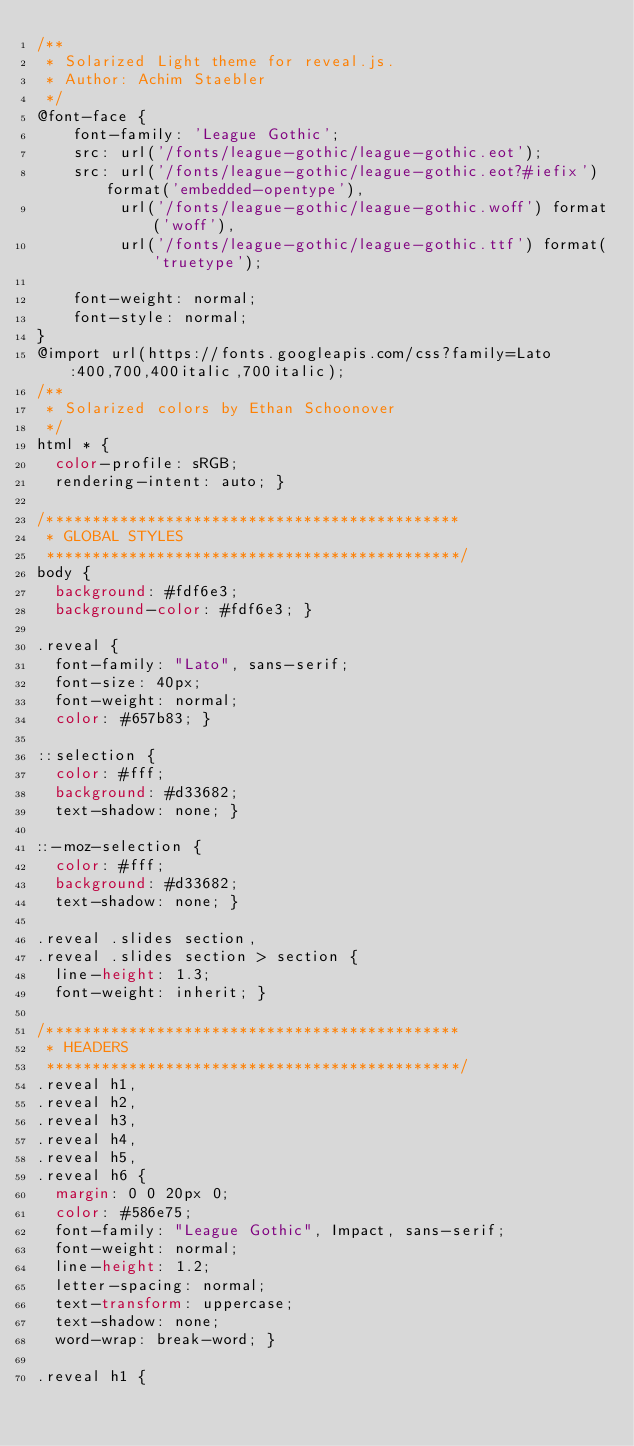Convert code to text. <code><loc_0><loc_0><loc_500><loc_500><_CSS_>/**
 * Solarized Light theme for reveal.js.
 * Author: Achim Staebler
 */
@font-face {
    font-family: 'League Gothic';
    src: url('/fonts/league-gothic/league-gothic.eot');
    src: url('/fonts/league-gothic/league-gothic.eot?#iefix') format('embedded-opentype'),
         url('/fonts/league-gothic/league-gothic.woff') format('woff'),
         url('/fonts/league-gothic/league-gothic.ttf') format('truetype');

    font-weight: normal;
    font-style: normal;
}
@import url(https://fonts.googleapis.com/css?family=Lato:400,700,400italic,700italic);
/**
 * Solarized colors by Ethan Schoonover
 */
html * {
  color-profile: sRGB;
  rendering-intent: auto; }

/*********************************************
 * GLOBAL STYLES
 *********************************************/
body {
  background: #fdf6e3;
  background-color: #fdf6e3; }

.reveal {
  font-family: "Lato", sans-serif;
  font-size: 40px;
  font-weight: normal;
  color: #657b83; }

::selection {
  color: #fff;
  background: #d33682;
  text-shadow: none; }

::-moz-selection {
  color: #fff;
  background: #d33682;
  text-shadow: none; }

.reveal .slides section,
.reveal .slides section > section {
  line-height: 1.3;
  font-weight: inherit; }

/*********************************************
 * HEADERS
 *********************************************/
.reveal h1,
.reveal h2,
.reveal h3,
.reveal h4,
.reveal h5,
.reveal h6 {
  margin: 0 0 20px 0;
  color: #586e75;
  font-family: "League Gothic", Impact, sans-serif;
  font-weight: normal;
  line-height: 1.2;
  letter-spacing: normal;
  text-transform: uppercase;
  text-shadow: none;
  word-wrap: break-word; }

.reveal h1 {</code> 